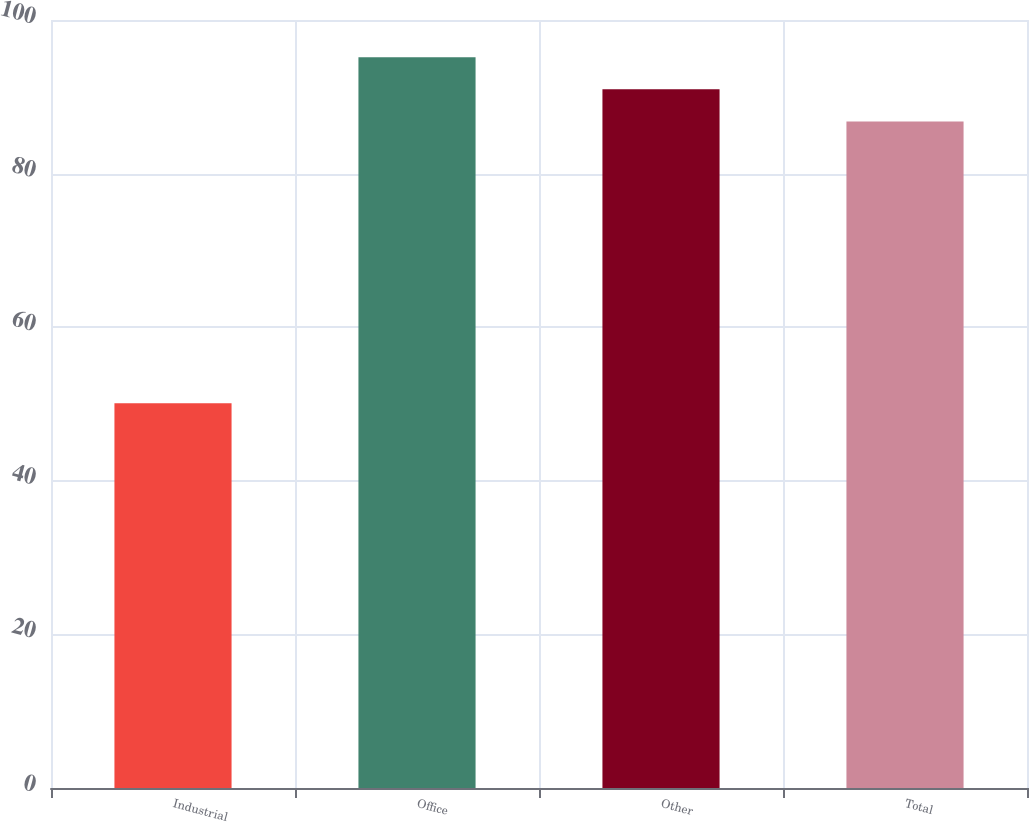Convert chart to OTSL. <chart><loc_0><loc_0><loc_500><loc_500><bar_chart><fcel>Industrial<fcel>Office<fcel>Other<fcel>Total<nl><fcel>50.1<fcel>95.14<fcel>90.97<fcel>86.8<nl></chart> 